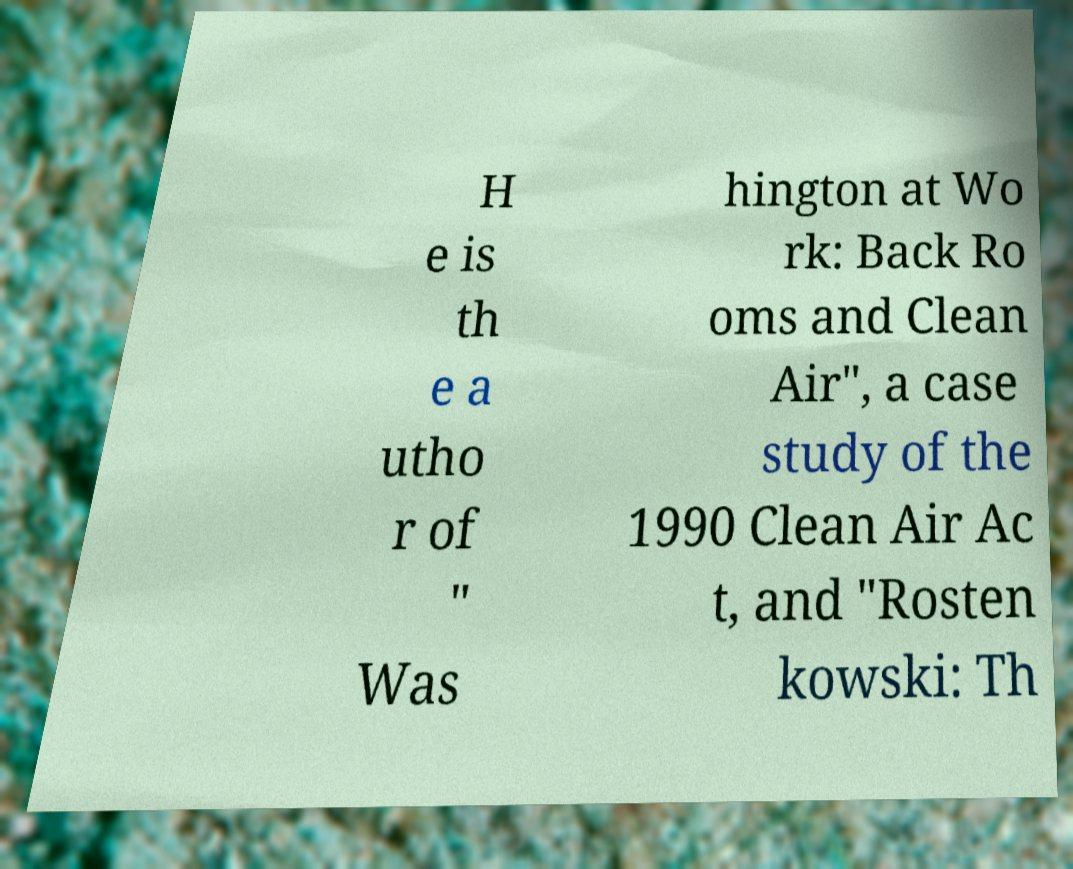I need the written content from this picture converted into text. Can you do that? H e is th e a utho r of " Was hington at Wo rk: Back Ro oms and Clean Air", a case study of the 1990 Clean Air Ac t, and "Rosten kowski: Th 